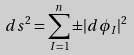<formula> <loc_0><loc_0><loc_500><loc_500>d s ^ { 2 } = \sum _ { I = 1 } ^ { n } \pm | d \phi _ { I } | ^ { 2 }</formula> 